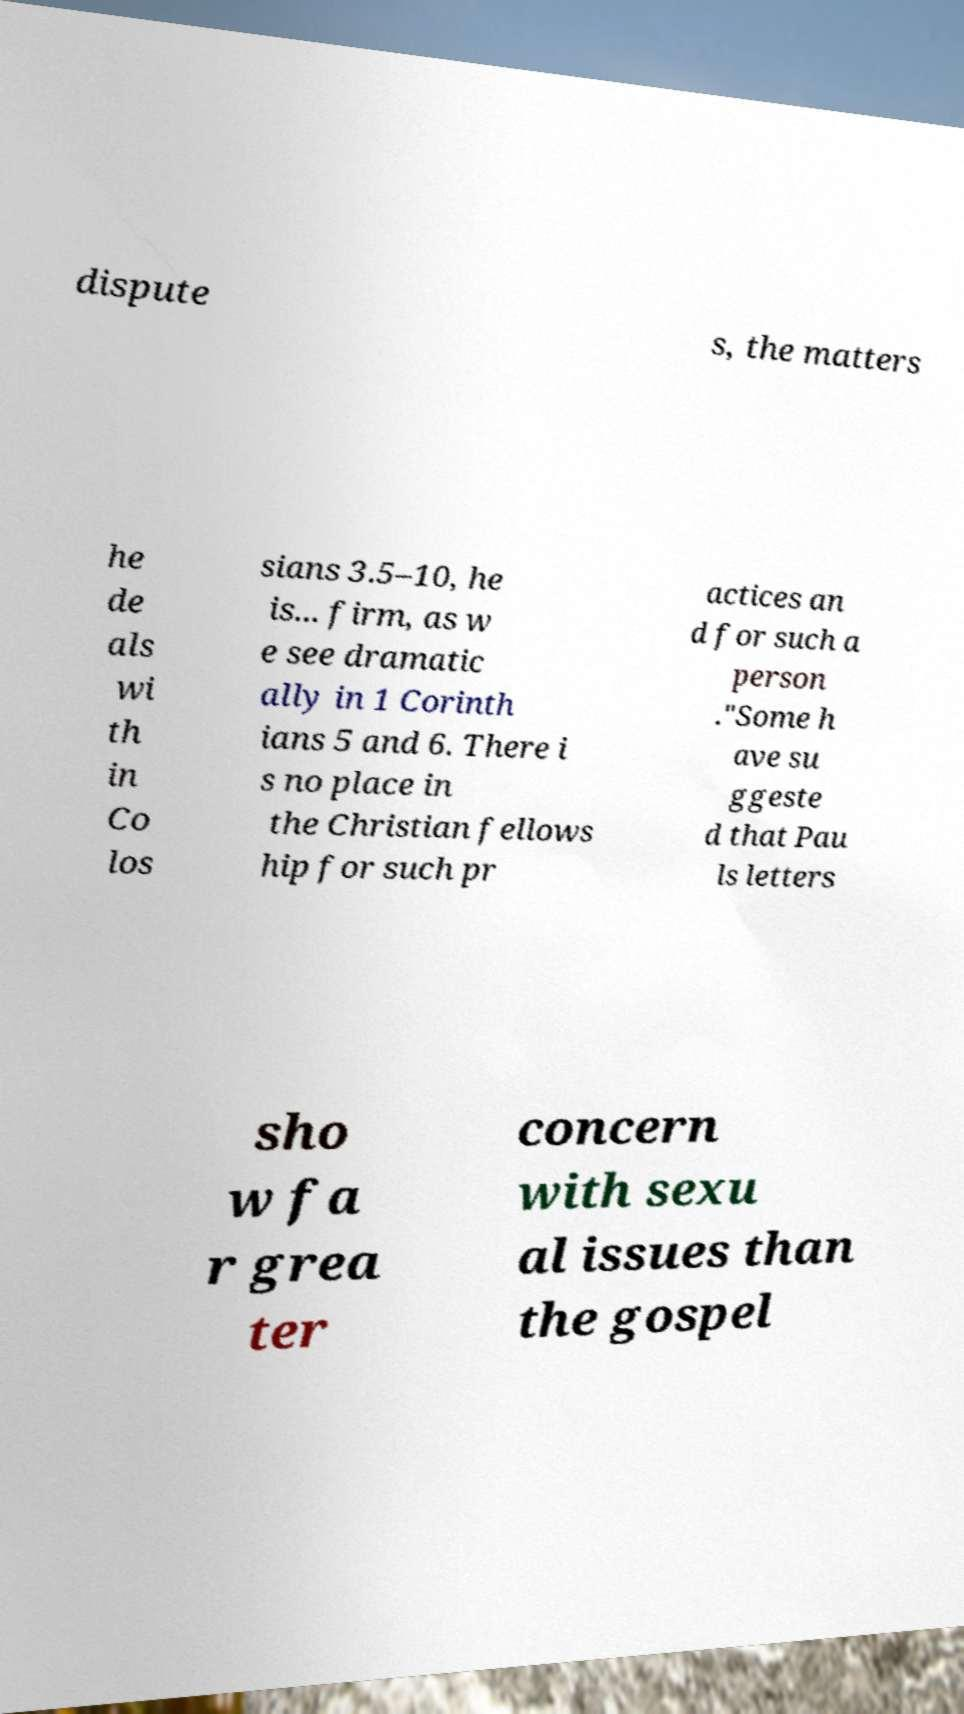Please read and relay the text visible in this image. What does it say? dispute s, the matters he de als wi th in Co los sians 3.5–10, he is... firm, as w e see dramatic ally in 1 Corinth ians 5 and 6. There i s no place in the Christian fellows hip for such pr actices an d for such a person ."Some h ave su ggeste d that Pau ls letters sho w fa r grea ter concern with sexu al issues than the gospel 